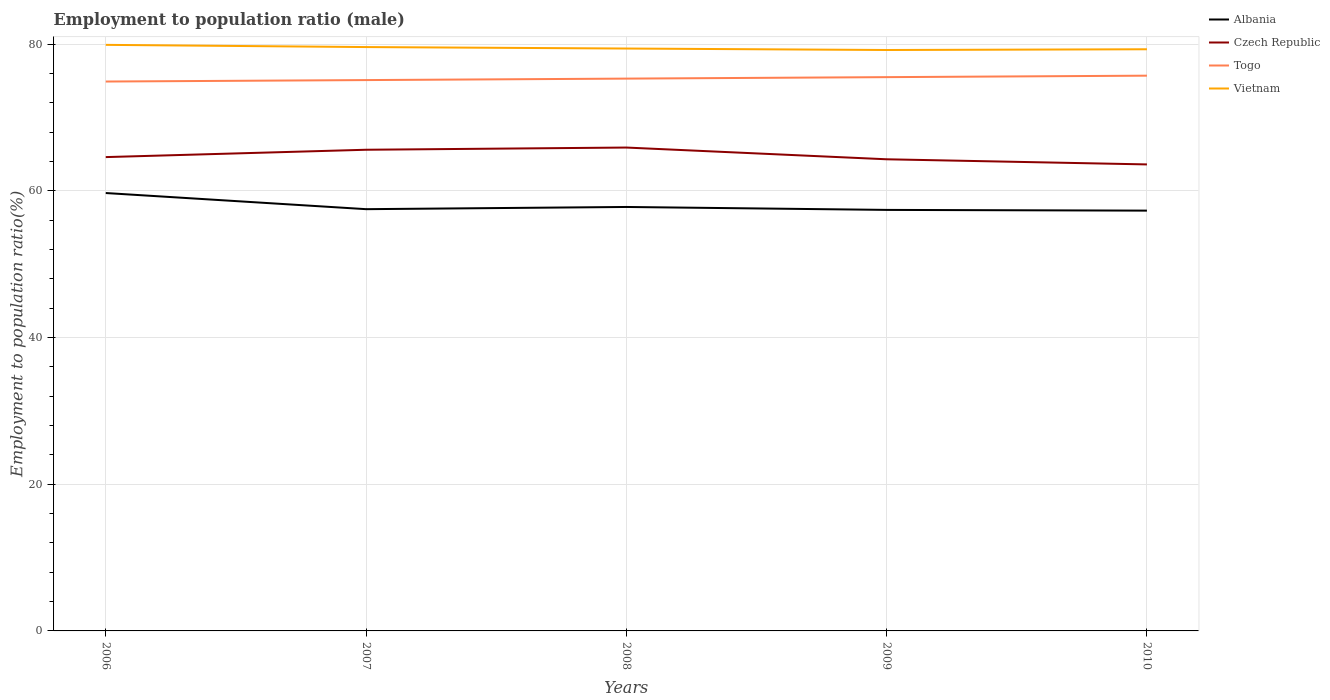Is the number of lines equal to the number of legend labels?
Keep it short and to the point. Yes. Across all years, what is the maximum employment to population ratio in Togo?
Ensure brevity in your answer.  74.9. What is the total employment to population ratio in Czech Republic in the graph?
Provide a short and direct response. 2. What is the difference between the highest and the second highest employment to population ratio in Albania?
Offer a terse response. 2.4. Is the employment to population ratio in Albania strictly greater than the employment to population ratio in Czech Republic over the years?
Ensure brevity in your answer.  Yes. How many lines are there?
Keep it short and to the point. 4. How many years are there in the graph?
Give a very brief answer. 5. Are the values on the major ticks of Y-axis written in scientific E-notation?
Provide a succinct answer. No. Does the graph contain any zero values?
Give a very brief answer. No. Does the graph contain grids?
Give a very brief answer. Yes. What is the title of the graph?
Ensure brevity in your answer.  Employment to population ratio (male). What is the label or title of the X-axis?
Your response must be concise. Years. What is the Employment to population ratio(%) in Albania in 2006?
Your response must be concise. 59.7. What is the Employment to population ratio(%) in Czech Republic in 2006?
Ensure brevity in your answer.  64.6. What is the Employment to population ratio(%) of Togo in 2006?
Provide a succinct answer. 74.9. What is the Employment to population ratio(%) of Vietnam in 2006?
Offer a terse response. 79.9. What is the Employment to population ratio(%) in Albania in 2007?
Offer a terse response. 57.5. What is the Employment to population ratio(%) of Czech Republic in 2007?
Offer a terse response. 65.6. What is the Employment to population ratio(%) of Togo in 2007?
Your answer should be compact. 75.1. What is the Employment to population ratio(%) of Vietnam in 2007?
Your response must be concise. 79.6. What is the Employment to population ratio(%) of Albania in 2008?
Your answer should be very brief. 57.8. What is the Employment to population ratio(%) in Czech Republic in 2008?
Give a very brief answer. 65.9. What is the Employment to population ratio(%) in Togo in 2008?
Provide a short and direct response. 75.3. What is the Employment to population ratio(%) in Vietnam in 2008?
Provide a succinct answer. 79.4. What is the Employment to population ratio(%) of Albania in 2009?
Your answer should be compact. 57.4. What is the Employment to population ratio(%) in Czech Republic in 2009?
Provide a short and direct response. 64.3. What is the Employment to population ratio(%) in Togo in 2009?
Offer a terse response. 75.5. What is the Employment to population ratio(%) in Vietnam in 2009?
Make the answer very short. 79.2. What is the Employment to population ratio(%) in Albania in 2010?
Provide a short and direct response. 57.3. What is the Employment to population ratio(%) of Czech Republic in 2010?
Give a very brief answer. 63.6. What is the Employment to population ratio(%) in Togo in 2010?
Your answer should be very brief. 75.7. What is the Employment to population ratio(%) of Vietnam in 2010?
Keep it short and to the point. 79.3. Across all years, what is the maximum Employment to population ratio(%) of Albania?
Give a very brief answer. 59.7. Across all years, what is the maximum Employment to population ratio(%) of Czech Republic?
Provide a short and direct response. 65.9. Across all years, what is the maximum Employment to population ratio(%) in Togo?
Provide a short and direct response. 75.7. Across all years, what is the maximum Employment to population ratio(%) in Vietnam?
Offer a terse response. 79.9. Across all years, what is the minimum Employment to population ratio(%) of Albania?
Provide a short and direct response. 57.3. Across all years, what is the minimum Employment to population ratio(%) in Czech Republic?
Provide a succinct answer. 63.6. Across all years, what is the minimum Employment to population ratio(%) of Togo?
Your answer should be compact. 74.9. Across all years, what is the minimum Employment to population ratio(%) in Vietnam?
Keep it short and to the point. 79.2. What is the total Employment to population ratio(%) in Albania in the graph?
Your answer should be very brief. 289.7. What is the total Employment to population ratio(%) in Czech Republic in the graph?
Offer a terse response. 324. What is the total Employment to population ratio(%) of Togo in the graph?
Your answer should be very brief. 376.5. What is the total Employment to population ratio(%) in Vietnam in the graph?
Your response must be concise. 397.4. What is the difference between the Employment to population ratio(%) in Togo in 2006 and that in 2007?
Your answer should be compact. -0.2. What is the difference between the Employment to population ratio(%) in Vietnam in 2006 and that in 2007?
Offer a terse response. 0.3. What is the difference between the Employment to population ratio(%) of Albania in 2006 and that in 2008?
Your answer should be very brief. 1.9. What is the difference between the Employment to population ratio(%) of Czech Republic in 2006 and that in 2008?
Your answer should be compact. -1.3. What is the difference between the Employment to population ratio(%) in Vietnam in 2006 and that in 2008?
Give a very brief answer. 0.5. What is the difference between the Employment to population ratio(%) in Albania in 2006 and that in 2009?
Ensure brevity in your answer.  2.3. What is the difference between the Employment to population ratio(%) in Vietnam in 2006 and that in 2009?
Give a very brief answer. 0.7. What is the difference between the Employment to population ratio(%) in Albania in 2006 and that in 2010?
Provide a succinct answer. 2.4. What is the difference between the Employment to population ratio(%) in Togo in 2006 and that in 2010?
Provide a short and direct response. -0.8. What is the difference between the Employment to population ratio(%) of Vietnam in 2006 and that in 2010?
Offer a terse response. 0.6. What is the difference between the Employment to population ratio(%) in Albania in 2007 and that in 2008?
Keep it short and to the point. -0.3. What is the difference between the Employment to population ratio(%) in Czech Republic in 2007 and that in 2008?
Offer a terse response. -0.3. What is the difference between the Employment to population ratio(%) in Vietnam in 2007 and that in 2008?
Your answer should be very brief. 0.2. What is the difference between the Employment to population ratio(%) of Czech Republic in 2007 and that in 2009?
Offer a terse response. 1.3. What is the difference between the Employment to population ratio(%) of Vietnam in 2007 and that in 2009?
Keep it short and to the point. 0.4. What is the difference between the Employment to population ratio(%) of Albania in 2007 and that in 2010?
Ensure brevity in your answer.  0.2. What is the difference between the Employment to population ratio(%) of Togo in 2007 and that in 2010?
Keep it short and to the point. -0.6. What is the difference between the Employment to population ratio(%) in Vietnam in 2007 and that in 2010?
Give a very brief answer. 0.3. What is the difference between the Employment to population ratio(%) in Albania in 2008 and that in 2009?
Your answer should be very brief. 0.4. What is the difference between the Employment to population ratio(%) of Albania in 2008 and that in 2010?
Provide a short and direct response. 0.5. What is the difference between the Employment to population ratio(%) in Czech Republic in 2009 and that in 2010?
Keep it short and to the point. 0.7. What is the difference between the Employment to population ratio(%) in Albania in 2006 and the Employment to population ratio(%) in Togo in 2007?
Give a very brief answer. -15.4. What is the difference between the Employment to population ratio(%) in Albania in 2006 and the Employment to population ratio(%) in Vietnam in 2007?
Keep it short and to the point. -19.9. What is the difference between the Employment to population ratio(%) of Czech Republic in 2006 and the Employment to population ratio(%) of Togo in 2007?
Make the answer very short. -10.5. What is the difference between the Employment to population ratio(%) of Czech Republic in 2006 and the Employment to population ratio(%) of Vietnam in 2007?
Keep it short and to the point. -15. What is the difference between the Employment to population ratio(%) in Albania in 2006 and the Employment to population ratio(%) in Czech Republic in 2008?
Your answer should be very brief. -6.2. What is the difference between the Employment to population ratio(%) in Albania in 2006 and the Employment to population ratio(%) in Togo in 2008?
Offer a terse response. -15.6. What is the difference between the Employment to population ratio(%) of Albania in 2006 and the Employment to population ratio(%) of Vietnam in 2008?
Keep it short and to the point. -19.7. What is the difference between the Employment to population ratio(%) in Czech Republic in 2006 and the Employment to population ratio(%) in Togo in 2008?
Offer a very short reply. -10.7. What is the difference between the Employment to population ratio(%) of Czech Republic in 2006 and the Employment to population ratio(%) of Vietnam in 2008?
Your response must be concise. -14.8. What is the difference between the Employment to population ratio(%) of Togo in 2006 and the Employment to population ratio(%) of Vietnam in 2008?
Your response must be concise. -4.5. What is the difference between the Employment to population ratio(%) of Albania in 2006 and the Employment to population ratio(%) of Togo in 2009?
Give a very brief answer. -15.8. What is the difference between the Employment to population ratio(%) of Albania in 2006 and the Employment to population ratio(%) of Vietnam in 2009?
Offer a very short reply. -19.5. What is the difference between the Employment to population ratio(%) in Czech Republic in 2006 and the Employment to population ratio(%) in Togo in 2009?
Make the answer very short. -10.9. What is the difference between the Employment to population ratio(%) of Czech Republic in 2006 and the Employment to population ratio(%) of Vietnam in 2009?
Offer a terse response. -14.6. What is the difference between the Employment to population ratio(%) in Togo in 2006 and the Employment to population ratio(%) in Vietnam in 2009?
Your answer should be compact. -4.3. What is the difference between the Employment to population ratio(%) in Albania in 2006 and the Employment to population ratio(%) in Togo in 2010?
Give a very brief answer. -16. What is the difference between the Employment to population ratio(%) of Albania in 2006 and the Employment to population ratio(%) of Vietnam in 2010?
Make the answer very short. -19.6. What is the difference between the Employment to population ratio(%) in Czech Republic in 2006 and the Employment to population ratio(%) in Vietnam in 2010?
Provide a succinct answer. -14.7. What is the difference between the Employment to population ratio(%) of Albania in 2007 and the Employment to population ratio(%) of Togo in 2008?
Provide a succinct answer. -17.8. What is the difference between the Employment to population ratio(%) of Albania in 2007 and the Employment to population ratio(%) of Vietnam in 2008?
Ensure brevity in your answer.  -21.9. What is the difference between the Employment to population ratio(%) of Czech Republic in 2007 and the Employment to population ratio(%) of Togo in 2008?
Your answer should be very brief. -9.7. What is the difference between the Employment to population ratio(%) in Czech Republic in 2007 and the Employment to population ratio(%) in Vietnam in 2008?
Give a very brief answer. -13.8. What is the difference between the Employment to population ratio(%) in Togo in 2007 and the Employment to population ratio(%) in Vietnam in 2008?
Make the answer very short. -4.3. What is the difference between the Employment to population ratio(%) of Albania in 2007 and the Employment to population ratio(%) of Togo in 2009?
Your response must be concise. -18. What is the difference between the Employment to population ratio(%) of Albania in 2007 and the Employment to population ratio(%) of Vietnam in 2009?
Your response must be concise. -21.7. What is the difference between the Employment to population ratio(%) in Togo in 2007 and the Employment to population ratio(%) in Vietnam in 2009?
Keep it short and to the point. -4.1. What is the difference between the Employment to population ratio(%) in Albania in 2007 and the Employment to population ratio(%) in Czech Republic in 2010?
Keep it short and to the point. -6.1. What is the difference between the Employment to population ratio(%) of Albania in 2007 and the Employment to population ratio(%) of Togo in 2010?
Provide a succinct answer. -18.2. What is the difference between the Employment to population ratio(%) of Albania in 2007 and the Employment to population ratio(%) of Vietnam in 2010?
Make the answer very short. -21.8. What is the difference between the Employment to population ratio(%) of Czech Republic in 2007 and the Employment to population ratio(%) of Togo in 2010?
Ensure brevity in your answer.  -10.1. What is the difference between the Employment to population ratio(%) in Czech Republic in 2007 and the Employment to population ratio(%) in Vietnam in 2010?
Provide a succinct answer. -13.7. What is the difference between the Employment to population ratio(%) in Albania in 2008 and the Employment to population ratio(%) in Czech Republic in 2009?
Make the answer very short. -6.5. What is the difference between the Employment to population ratio(%) of Albania in 2008 and the Employment to population ratio(%) of Togo in 2009?
Provide a short and direct response. -17.7. What is the difference between the Employment to population ratio(%) in Albania in 2008 and the Employment to population ratio(%) in Vietnam in 2009?
Provide a short and direct response. -21.4. What is the difference between the Employment to population ratio(%) in Albania in 2008 and the Employment to population ratio(%) in Czech Republic in 2010?
Your response must be concise. -5.8. What is the difference between the Employment to population ratio(%) of Albania in 2008 and the Employment to population ratio(%) of Togo in 2010?
Provide a succinct answer. -17.9. What is the difference between the Employment to population ratio(%) in Albania in 2008 and the Employment to population ratio(%) in Vietnam in 2010?
Provide a short and direct response. -21.5. What is the difference between the Employment to population ratio(%) in Czech Republic in 2008 and the Employment to population ratio(%) in Vietnam in 2010?
Ensure brevity in your answer.  -13.4. What is the difference between the Employment to population ratio(%) in Togo in 2008 and the Employment to population ratio(%) in Vietnam in 2010?
Provide a succinct answer. -4. What is the difference between the Employment to population ratio(%) of Albania in 2009 and the Employment to population ratio(%) of Czech Republic in 2010?
Keep it short and to the point. -6.2. What is the difference between the Employment to population ratio(%) in Albania in 2009 and the Employment to population ratio(%) in Togo in 2010?
Your response must be concise. -18.3. What is the difference between the Employment to population ratio(%) in Albania in 2009 and the Employment to population ratio(%) in Vietnam in 2010?
Give a very brief answer. -21.9. What is the average Employment to population ratio(%) of Albania per year?
Make the answer very short. 57.94. What is the average Employment to population ratio(%) of Czech Republic per year?
Provide a short and direct response. 64.8. What is the average Employment to population ratio(%) of Togo per year?
Keep it short and to the point. 75.3. What is the average Employment to population ratio(%) in Vietnam per year?
Offer a very short reply. 79.48. In the year 2006, what is the difference between the Employment to population ratio(%) in Albania and Employment to population ratio(%) in Czech Republic?
Your response must be concise. -4.9. In the year 2006, what is the difference between the Employment to population ratio(%) of Albania and Employment to population ratio(%) of Togo?
Offer a very short reply. -15.2. In the year 2006, what is the difference between the Employment to population ratio(%) in Albania and Employment to population ratio(%) in Vietnam?
Provide a succinct answer. -20.2. In the year 2006, what is the difference between the Employment to population ratio(%) in Czech Republic and Employment to population ratio(%) in Vietnam?
Offer a terse response. -15.3. In the year 2006, what is the difference between the Employment to population ratio(%) of Togo and Employment to population ratio(%) of Vietnam?
Make the answer very short. -5. In the year 2007, what is the difference between the Employment to population ratio(%) in Albania and Employment to population ratio(%) in Togo?
Provide a succinct answer. -17.6. In the year 2007, what is the difference between the Employment to population ratio(%) in Albania and Employment to population ratio(%) in Vietnam?
Ensure brevity in your answer.  -22.1. In the year 2007, what is the difference between the Employment to population ratio(%) of Czech Republic and Employment to population ratio(%) of Togo?
Offer a terse response. -9.5. In the year 2007, what is the difference between the Employment to population ratio(%) in Czech Republic and Employment to population ratio(%) in Vietnam?
Your response must be concise. -14. In the year 2007, what is the difference between the Employment to population ratio(%) of Togo and Employment to population ratio(%) of Vietnam?
Offer a very short reply. -4.5. In the year 2008, what is the difference between the Employment to population ratio(%) of Albania and Employment to population ratio(%) of Togo?
Your response must be concise. -17.5. In the year 2008, what is the difference between the Employment to population ratio(%) in Albania and Employment to population ratio(%) in Vietnam?
Make the answer very short. -21.6. In the year 2008, what is the difference between the Employment to population ratio(%) in Togo and Employment to population ratio(%) in Vietnam?
Keep it short and to the point. -4.1. In the year 2009, what is the difference between the Employment to population ratio(%) of Albania and Employment to population ratio(%) of Togo?
Your answer should be very brief. -18.1. In the year 2009, what is the difference between the Employment to population ratio(%) of Albania and Employment to population ratio(%) of Vietnam?
Offer a very short reply. -21.8. In the year 2009, what is the difference between the Employment to population ratio(%) in Czech Republic and Employment to population ratio(%) in Togo?
Make the answer very short. -11.2. In the year 2009, what is the difference between the Employment to population ratio(%) in Czech Republic and Employment to population ratio(%) in Vietnam?
Provide a succinct answer. -14.9. In the year 2010, what is the difference between the Employment to population ratio(%) of Albania and Employment to population ratio(%) of Togo?
Offer a terse response. -18.4. In the year 2010, what is the difference between the Employment to population ratio(%) in Albania and Employment to population ratio(%) in Vietnam?
Make the answer very short. -22. In the year 2010, what is the difference between the Employment to population ratio(%) of Czech Republic and Employment to population ratio(%) of Togo?
Provide a succinct answer. -12.1. In the year 2010, what is the difference between the Employment to population ratio(%) of Czech Republic and Employment to population ratio(%) of Vietnam?
Offer a terse response. -15.7. What is the ratio of the Employment to population ratio(%) of Albania in 2006 to that in 2007?
Provide a short and direct response. 1.04. What is the ratio of the Employment to population ratio(%) in Czech Republic in 2006 to that in 2007?
Your response must be concise. 0.98. What is the ratio of the Employment to population ratio(%) in Togo in 2006 to that in 2007?
Provide a short and direct response. 1. What is the ratio of the Employment to population ratio(%) of Albania in 2006 to that in 2008?
Offer a terse response. 1.03. What is the ratio of the Employment to population ratio(%) of Czech Republic in 2006 to that in 2008?
Provide a succinct answer. 0.98. What is the ratio of the Employment to population ratio(%) of Togo in 2006 to that in 2008?
Your answer should be compact. 0.99. What is the ratio of the Employment to population ratio(%) of Albania in 2006 to that in 2009?
Offer a very short reply. 1.04. What is the ratio of the Employment to population ratio(%) of Vietnam in 2006 to that in 2009?
Keep it short and to the point. 1.01. What is the ratio of the Employment to population ratio(%) of Albania in 2006 to that in 2010?
Make the answer very short. 1.04. What is the ratio of the Employment to population ratio(%) in Czech Republic in 2006 to that in 2010?
Your answer should be compact. 1.02. What is the ratio of the Employment to population ratio(%) of Togo in 2006 to that in 2010?
Ensure brevity in your answer.  0.99. What is the ratio of the Employment to population ratio(%) in Vietnam in 2006 to that in 2010?
Your answer should be compact. 1.01. What is the ratio of the Employment to population ratio(%) in Togo in 2007 to that in 2008?
Ensure brevity in your answer.  1. What is the ratio of the Employment to population ratio(%) of Czech Republic in 2007 to that in 2009?
Keep it short and to the point. 1.02. What is the ratio of the Employment to population ratio(%) of Togo in 2007 to that in 2009?
Make the answer very short. 0.99. What is the ratio of the Employment to population ratio(%) of Czech Republic in 2007 to that in 2010?
Provide a succinct answer. 1.03. What is the ratio of the Employment to population ratio(%) in Vietnam in 2007 to that in 2010?
Keep it short and to the point. 1. What is the ratio of the Employment to population ratio(%) of Albania in 2008 to that in 2009?
Offer a terse response. 1.01. What is the ratio of the Employment to population ratio(%) in Czech Republic in 2008 to that in 2009?
Ensure brevity in your answer.  1.02. What is the ratio of the Employment to population ratio(%) of Vietnam in 2008 to that in 2009?
Your response must be concise. 1. What is the ratio of the Employment to population ratio(%) of Albania in 2008 to that in 2010?
Keep it short and to the point. 1.01. What is the ratio of the Employment to population ratio(%) of Czech Republic in 2008 to that in 2010?
Provide a short and direct response. 1.04. What is the ratio of the Employment to population ratio(%) in Togo in 2008 to that in 2010?
Your answer should be very brief. 0.99. What is the ratio of the Employment to population ratio(%) in Czech Republic in 2009 to that in 2010?
Give a very brief answer. 1.01. What is the ratio of the Employment to population ratio(%) in Vietnam in 2009 to that in 2010?
Give a very brief answer. 1. What is the difference between the highest and the second highest Employment to population ratio(%) of Albania?
Offer a terse response. 1.9. What is the difference between the highest and the second highest Employment to population ratio(%) in Czech Republic?
Offer a terse response. 0.3. What is the difference between the highest and the second highest Employment to population ratio(%) of Togo?
Provide a short and direct response. 0.2. What is the difference between the highest and the second highest Employment to population ratio(%) of Vietnam?
Offer a very short reply. 0.3. What is the difference between the highest and the lowest Employment to population ratio(%) in Albania?
Provide a succinct answer. 2.4. What is the difference between the highest and the lowest Employment to population ratio(%) in Vietnam?
Your answer should be compact. 0.7. 